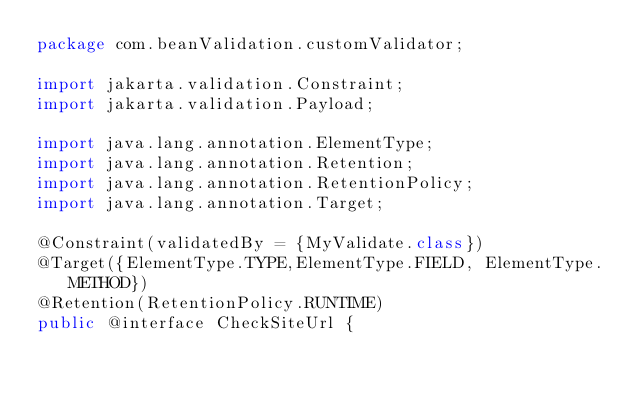<code> <loc_0><loc_0><loc_500><loc_500><_Java_>package com.beanValidation.customValidator;

import jakarta.validation.Constraint;
import jakarta.validation.Payload;

import java.lang.annotation.ElementType;
import java.lang.annotation.Retention;
import java.lang.annotation.RetentionPolicy;
import java.lang.annotation.Target;

@Constraint(validatedBy = {MyValidate.class})
@Target({ElementType.TYPE,ElementType.FIELD, ElementType.METHOD})
@Retention(RetentionPolicy.RUNTIME)
public @interface CheckSiteUrl {</code> 